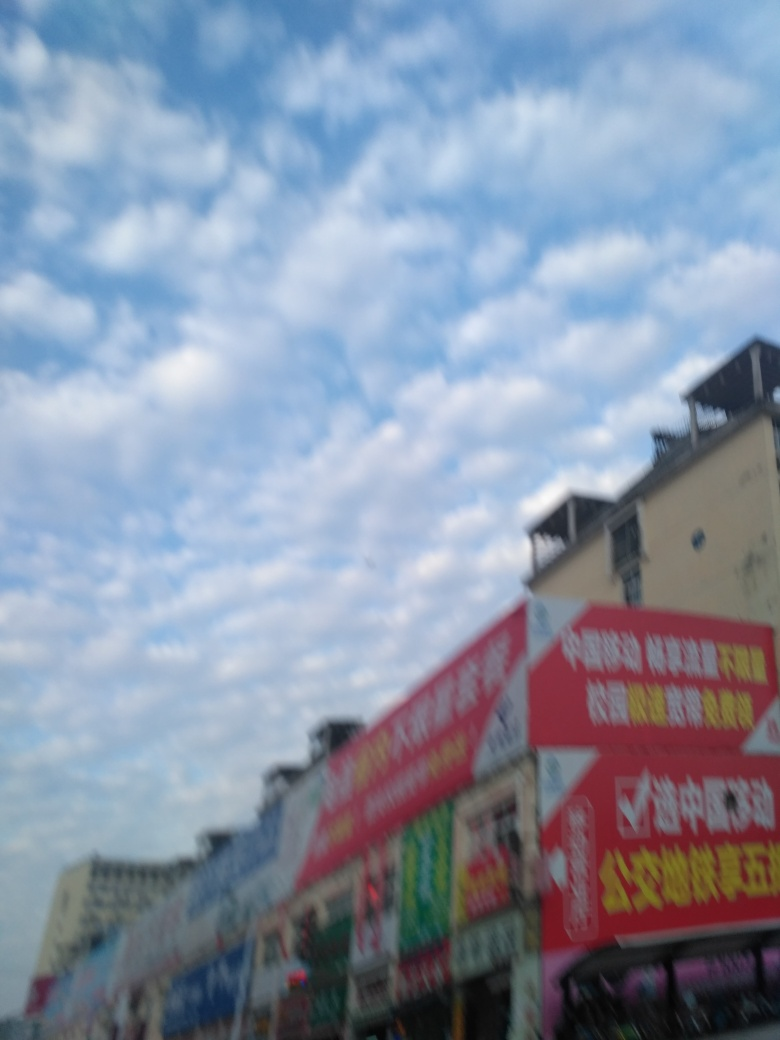What type of area does this image seem to depict? The image suggests a commercial area due to the presence of multiple advertisement boards and signages. It seems to be a bustling marketplace or a street with various shops based on the array of different advertisements. Unfortunately, specifics about the area cannot be accurately provided because of the image's lack of clarity. 